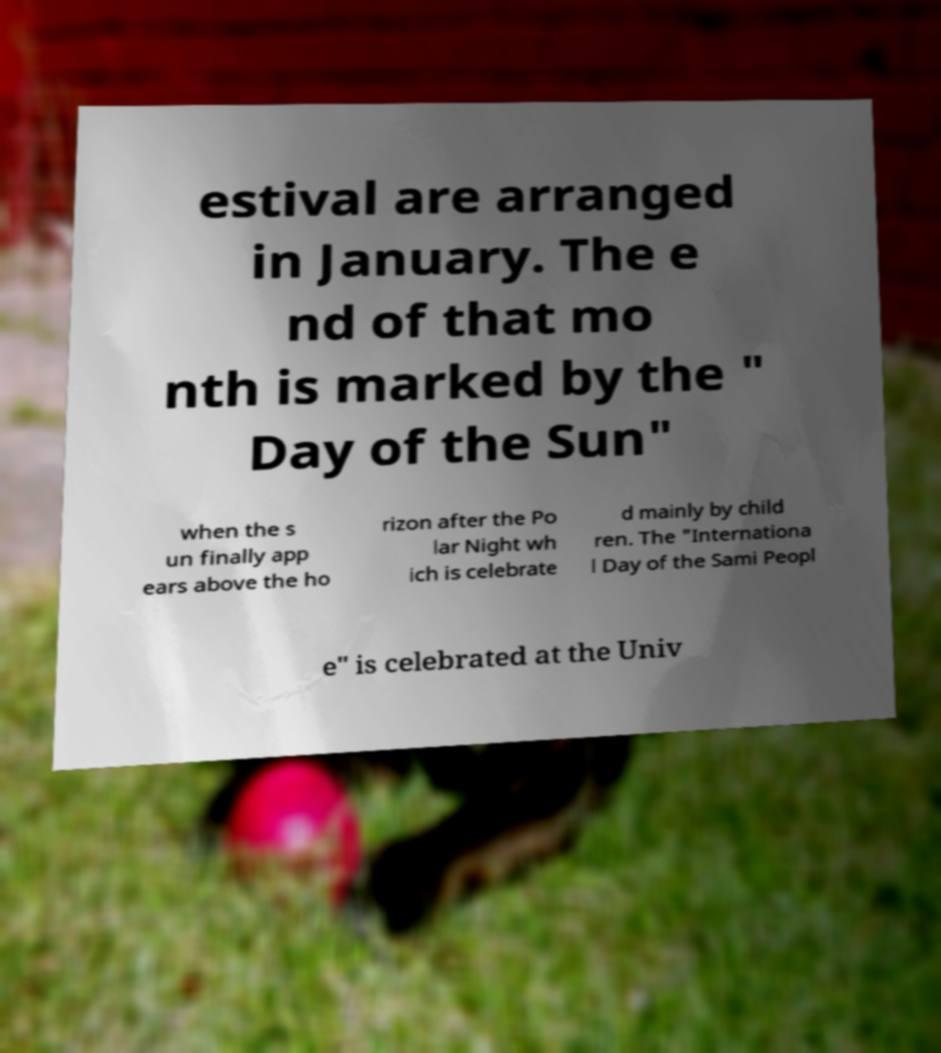There's text embedded in this image that I need extracted. Can you transcribe it verbatim? estival are arranged in January. The e nd of that mo nth is marked by the " Day of the Sun" when the s un finally app ears above the ho rizon after the Po lar Night wh ich is celebrate d mainly by child ren. The "Internationa l Day of the Sami Peopl e" is celebrated at the Univ 